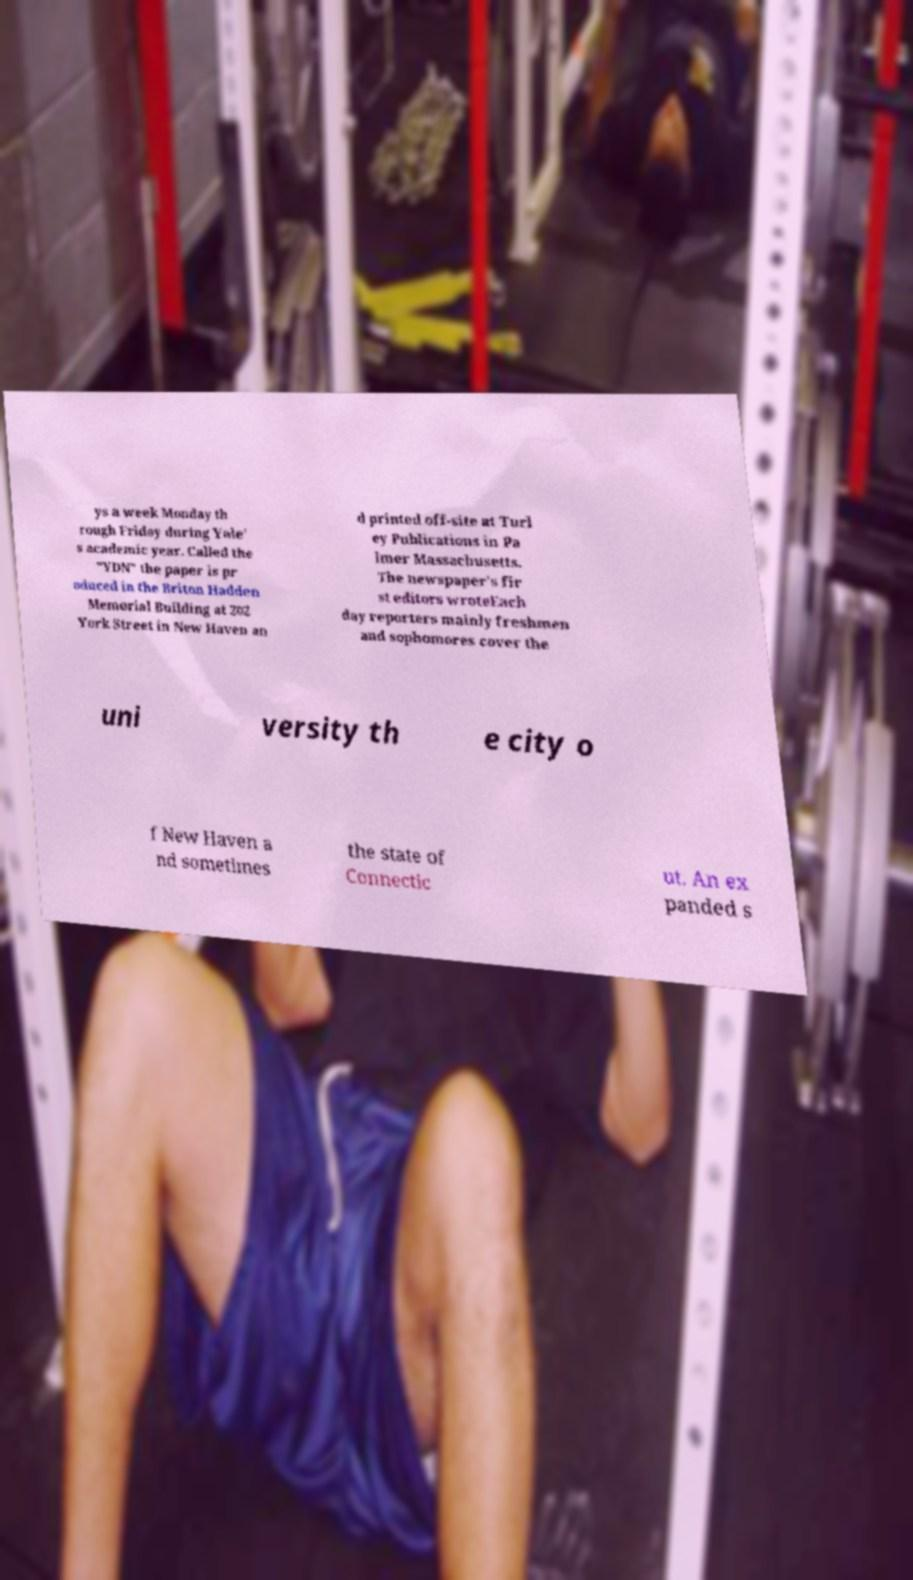Please read and relay the text visible in this image. What does it say? ys a week Monday th rough Friday during Yale' s academic year. Called the "YDN" the paper is pr oduced in the Briton Hadden Memorial Building at 202 York Street in New Haven an d printed off-site at Turl ey Publications in Pa lmer Massachusetts. The newspaper's fir st editors wroteEach day reporters mainly freshmen and sophomores cover the uni versity th e city o f New Haven a nd sometimes the state of Connectic ut. An ex panded s 